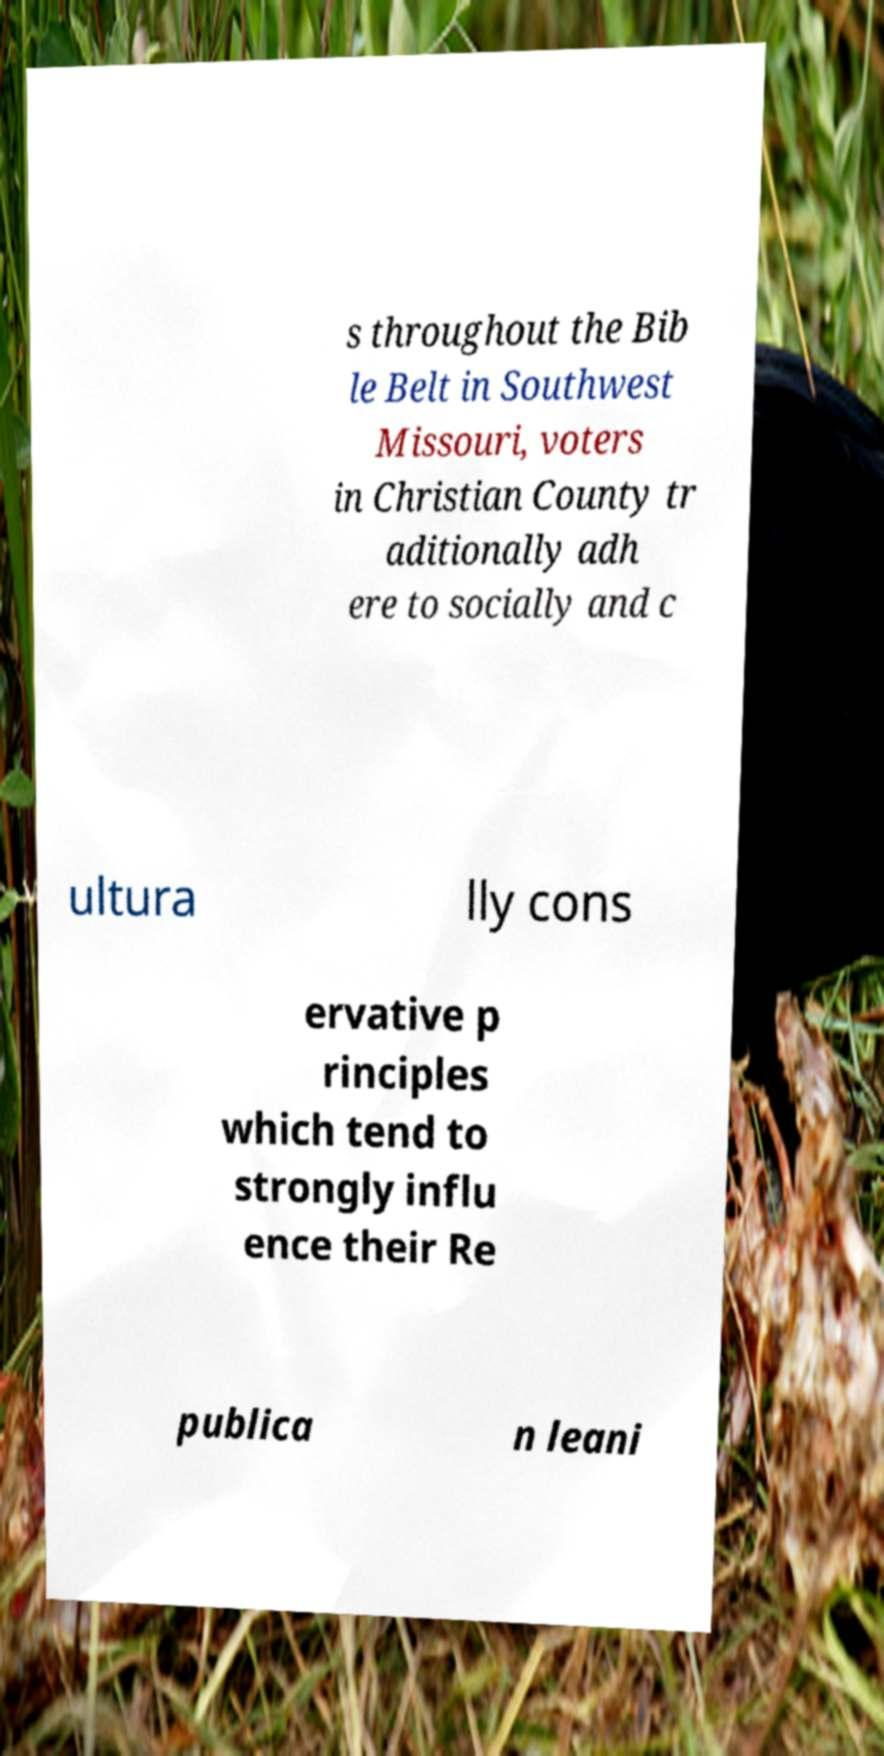For documentation purposes, I need the text within this image transcribed. Could you provide that? s throughout the Bib le Belt in Southwest Missouri, voters in Christian County tr aditionally adh ere to socially and c ultura lly cons ervative p rinciples which tend to strongly influ ence their Re publica n leani 